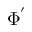<formula> <loc_0><loc_0><loc_500><loc_500>\Phi ^ { ^ { \prime } }</formula> 